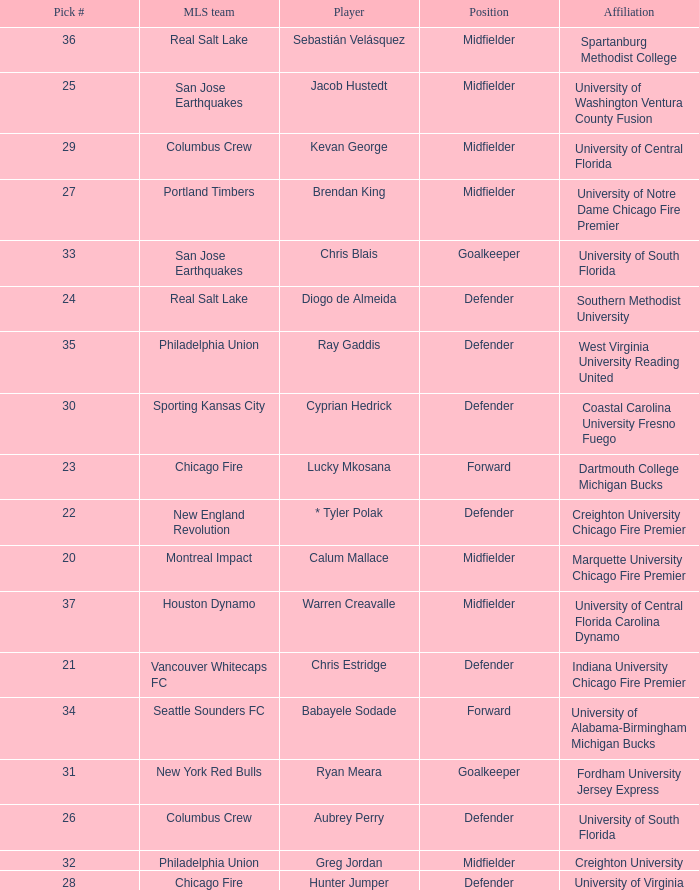What MLS team picked Babayele Sodade? Seattle Sounders FC. 